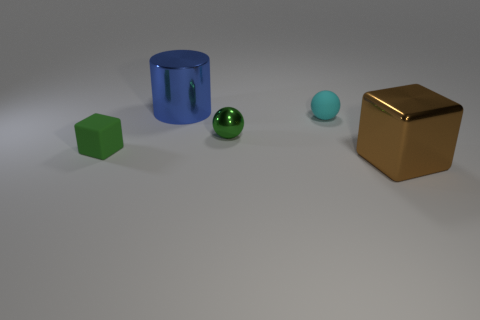Add 4 cyan matte spheres. How many objects exist? 9 Subtract 1 green balls. How many objects are left? 4 Subtract all cylinders. How many objects are left? 4 Subtract all blue blocks. Subtract all purple balls. How many blocks are left? 2 Subtract all blue cylinders. How many green cubes are left? 1 Subtract all big brown metallic cubes. Subtract all green metallic spheres. How many objects are left? 3 Add 1 blue metallic cylinders. How many blue metallic cylinders are left? 2 Add 5 large blue cylinders. How many large blue cylinders exist? 6 